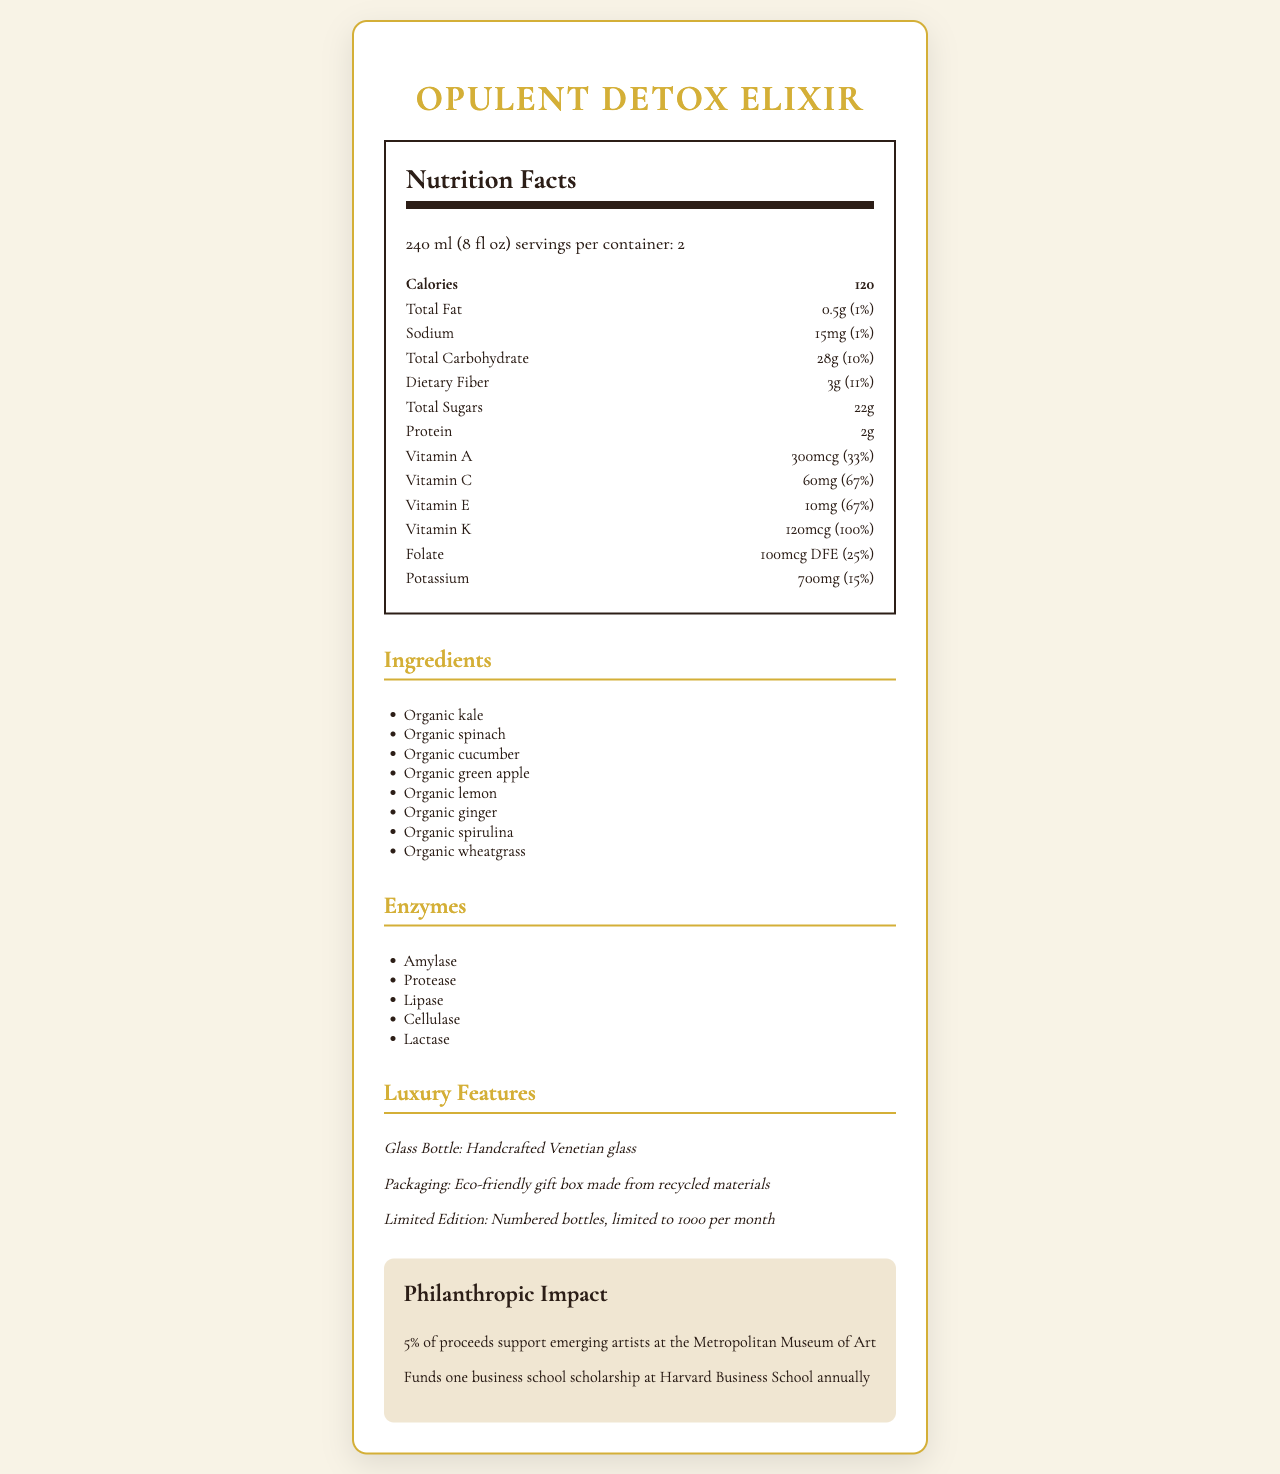what is the serving size? The serving size is stated at the beginning of the Nutrition Facts section.
Answer: 240 ml (8 fl oz) how many servings are there per container? The document states that there are 2 servings per container.
Answer: 2 what is the total calories per serving? The total calories per serving is listed under the Calories section in the Nutrition Facts.
Answer: 120 What are the total sugars per serving? The total sugars per serving is mentioned as 22g in the Nutrition Facts section.
Answer: 22g how much dietary fiber is in a serving, and what is its daily value percentage? The document mentions that each serving contains 3g of dietary fiber, which corresponds to 11% of the daily value.
Answer: 3g (11%) how much protein is in the Opulent Detox Elixir? The amount of protein is stated as 2g in the Nutrition Facts section.
Answer: 2g which vitamins provide the same daily value percentage per serving? A. Vitamin C and Vitamin E B. Vitamin A and Folate C. Vitamin K and Potassium D. Folate and Sodium Vitamin C and Vitamin E both provide 67% of the daily value per serving.
Answer: A. Vitamin C and Vitamin E what is the main ingredient in the Opulent Detox Elixir? A. Organic spinach B. Organic kale C. Organic green apple D. Organic cucumber The first ingredient listed is Organic kale, indicating it's the main ingredient.
Answer: B. Organic kale is the product gluten-free? The additional information specifies that the product is gluten-free.
Answer: Yes how much of the product in a container will contribute to the potassium intake as a percentage of the daily value? Each serving contains 15% of the daily value of Potassium. With 2 servings per container, it will be 15% * 2 = 30%.
Answer: 30% describe the luxury features of the Opulent Detox Elixir. The luxury features section describes these three major features of the product.
Answer: Luxury features include a handcrafted Venetian glass bottle, eco-friendly gift box made from recycled materials, and limited edition numbered bottles limited to 1000 per month. what type of enzymes are in the Opulent Detox Elixir? The enzymes section lists these five enzymes present in the product.
Answer: Amylase, Protease, Lipase, Cellulase, Lactase where can you buy this product? The document lists these locations as the exclusive availability spots for the product.
Answer: Neiman Marcus, Bergdorf Goodman, Harrods, and Private clubs in New York, London, and Dubai How does the Opulent Detox Elixir support philanthropy? The philanthropic impact section describes these contributions.
Answer: 5% of proceeds support emerging artists at the Metropolitan Museum of Art, and it funds one business school scholarship at Harvard Business School annually what is the total amount of folate in micrograms per serving and its daily value percentage? The folate content is listed as 100mcg DFE per serving, and its daily value percentage is 25%.
Answer: 100mcg DFE (25%) Can the exact amount of green apple in the product be determined from the document? The document lists green apple as an ingredient but does not specify the exact amount used in the product.
Answer: Not enough information 